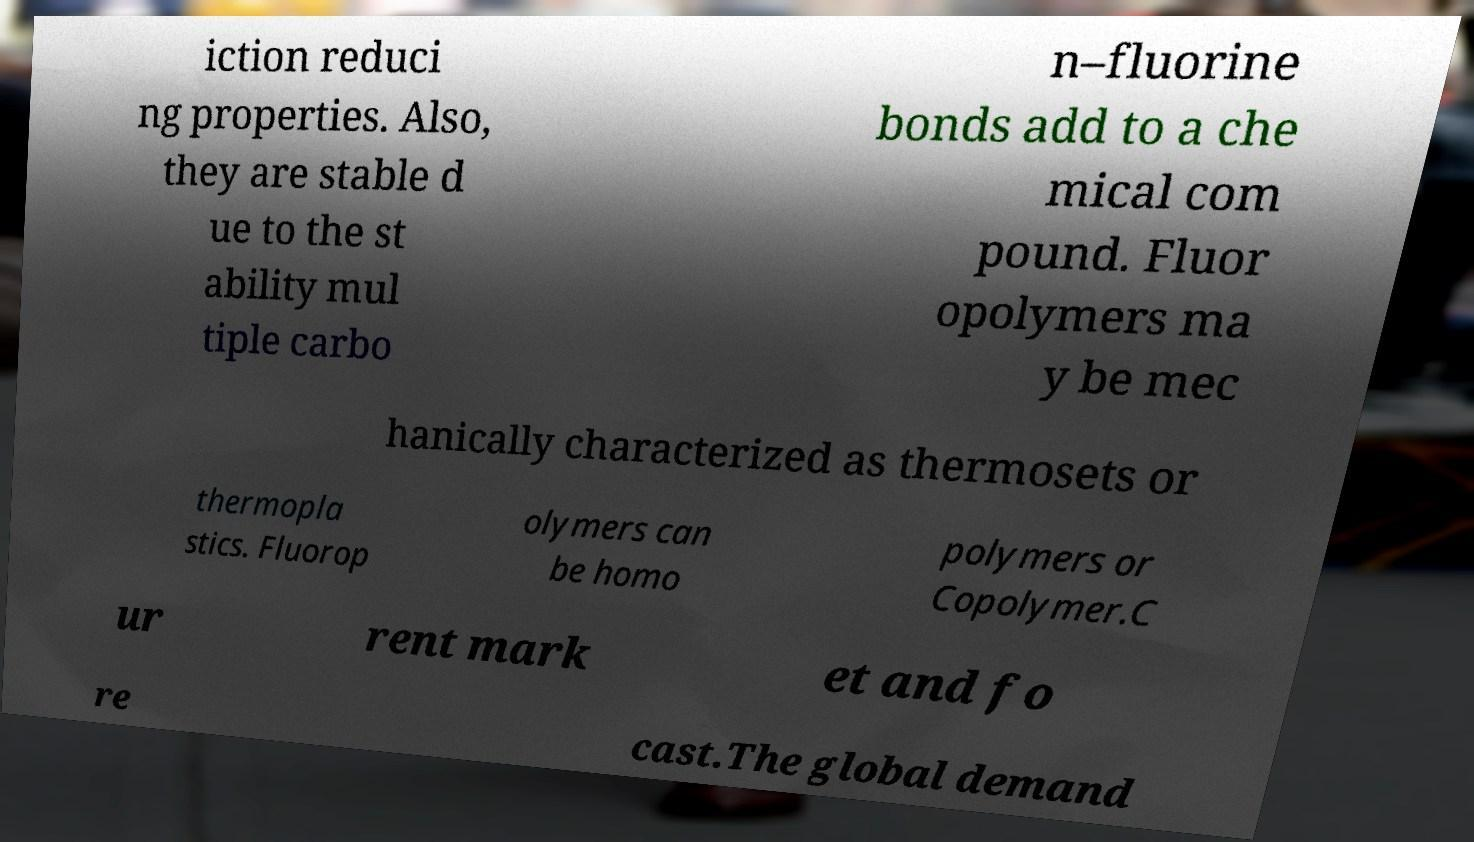For documentation purposes, I need the text within this image transcribed. Could you provide that? iction reduci ng properties. Also, they are stable d ue to the st ability mul tiple carbo n–fluorine bonds add to a che mical com pound. Fluor opolymers ma y be mec hanically characterized as thermosets or thermopla stics. Fluorop olymers can be homo polymers or Copolymer.C ur rent mark et and fo re cast.The global demand 